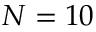Convert formula to latex. <formula><loc_0><loc_0><loc_500><loc_500>N = 1 0</formula> 